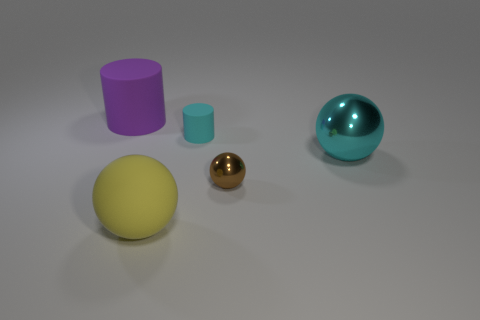What is the cyan sphere made of?
Keep it short and to the point. Metal. The large thing that is made of the same material as the big yellow ball is what color?
Make the answer very short. Purple. Is the cyan cylinder made of the same material as the large thing that is on the right side of the tiny rubber thing?
Your answer should be compact. No. How many big balls have the same material as the tiny brown thing?
Ensure brevity in your answer.  1. The large matte object on the right side of the big purple thing has what shape?
Offer a very short reply. Sphere. Do the big object that is to the left of the rubber sphere and the cyan object that is in front of the small cyan rubber cylinder have the same material?
Offer a very short reply. No. Are there any other shiny things of the same shape as the tiny cyan object?
Offer a very short reply. No. What number of things are large spheres behind the big yellow sphere or small gray spheres?
Ensure brevity in your answer.  1. Are there more purple matte cylinders to the left of the purple object than cyan matte cylinders behind the small cyan rubber cylinder?
Your answer should be very brief. No. How many rubber objects are either large objects or yellow balls?
Your answer should be compact. 2. 